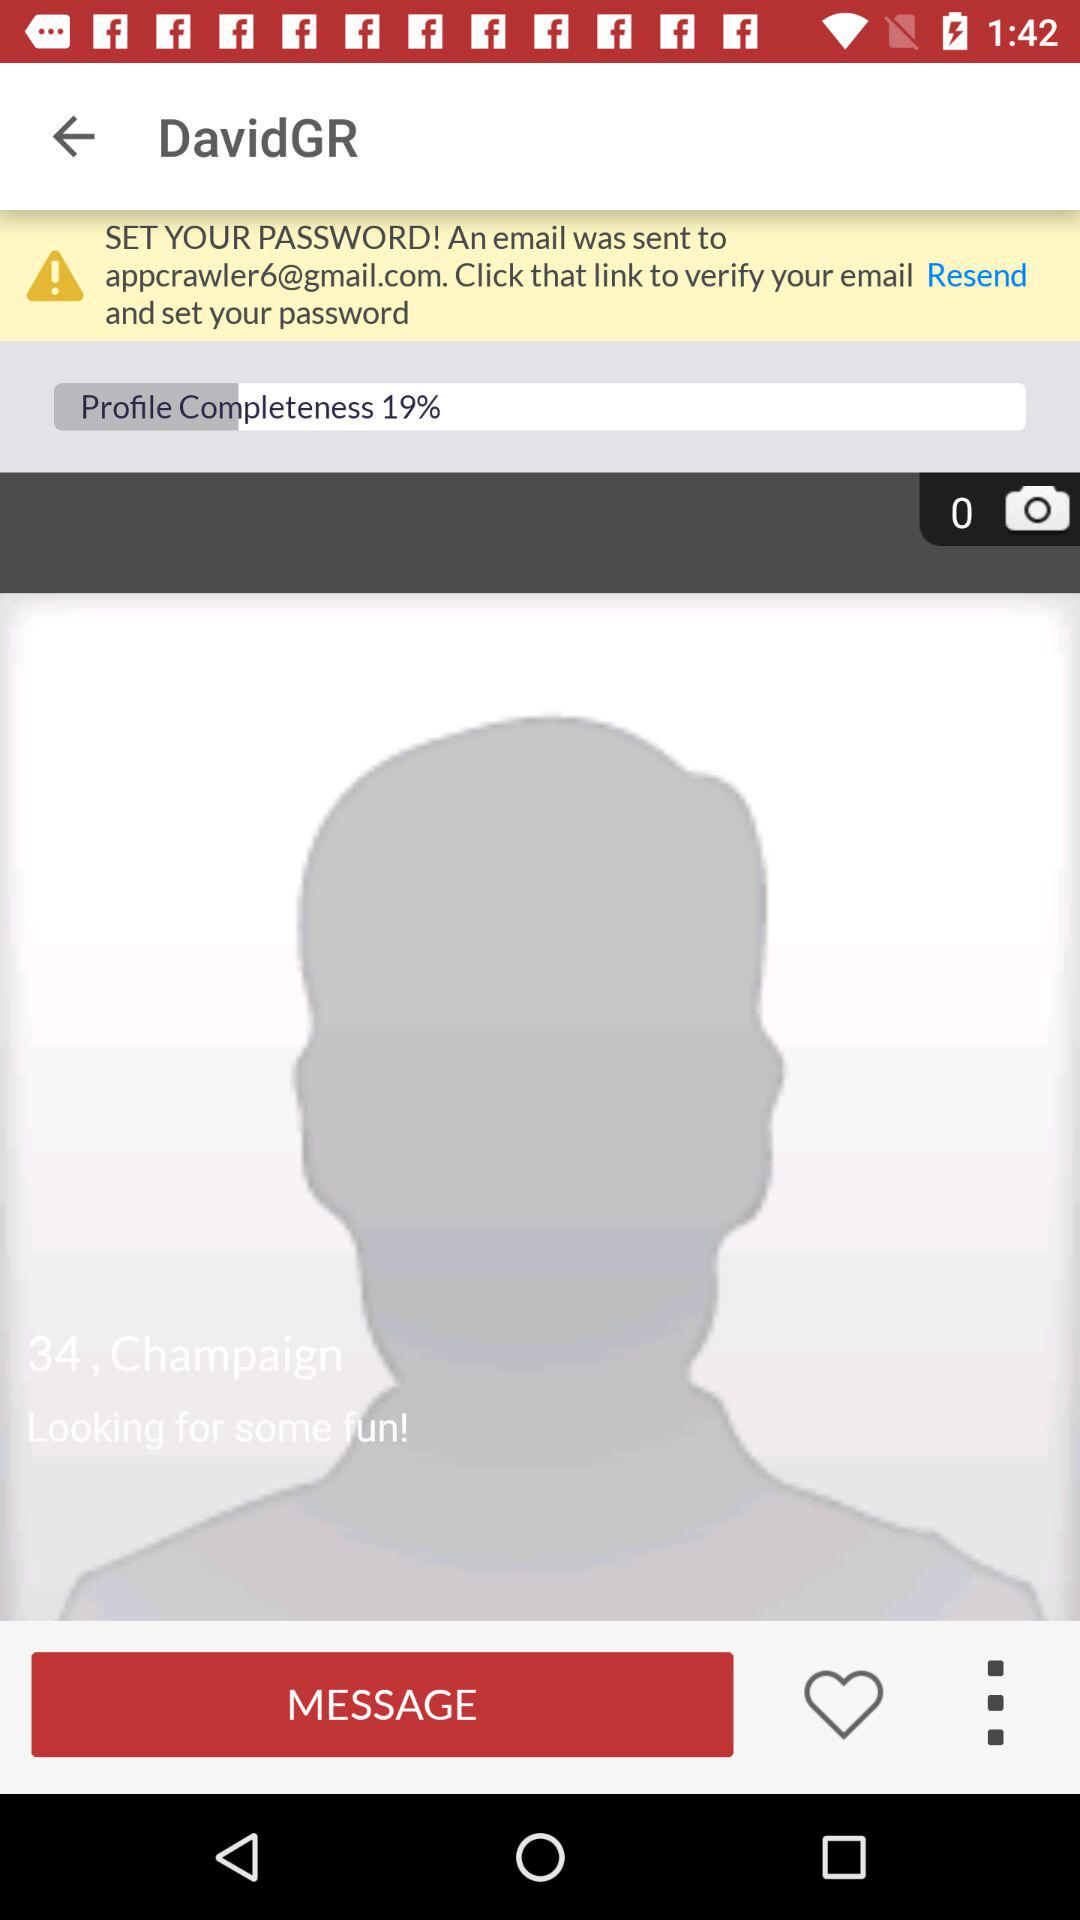How much of the profile has been completed? The profile has been completed by 19%. 